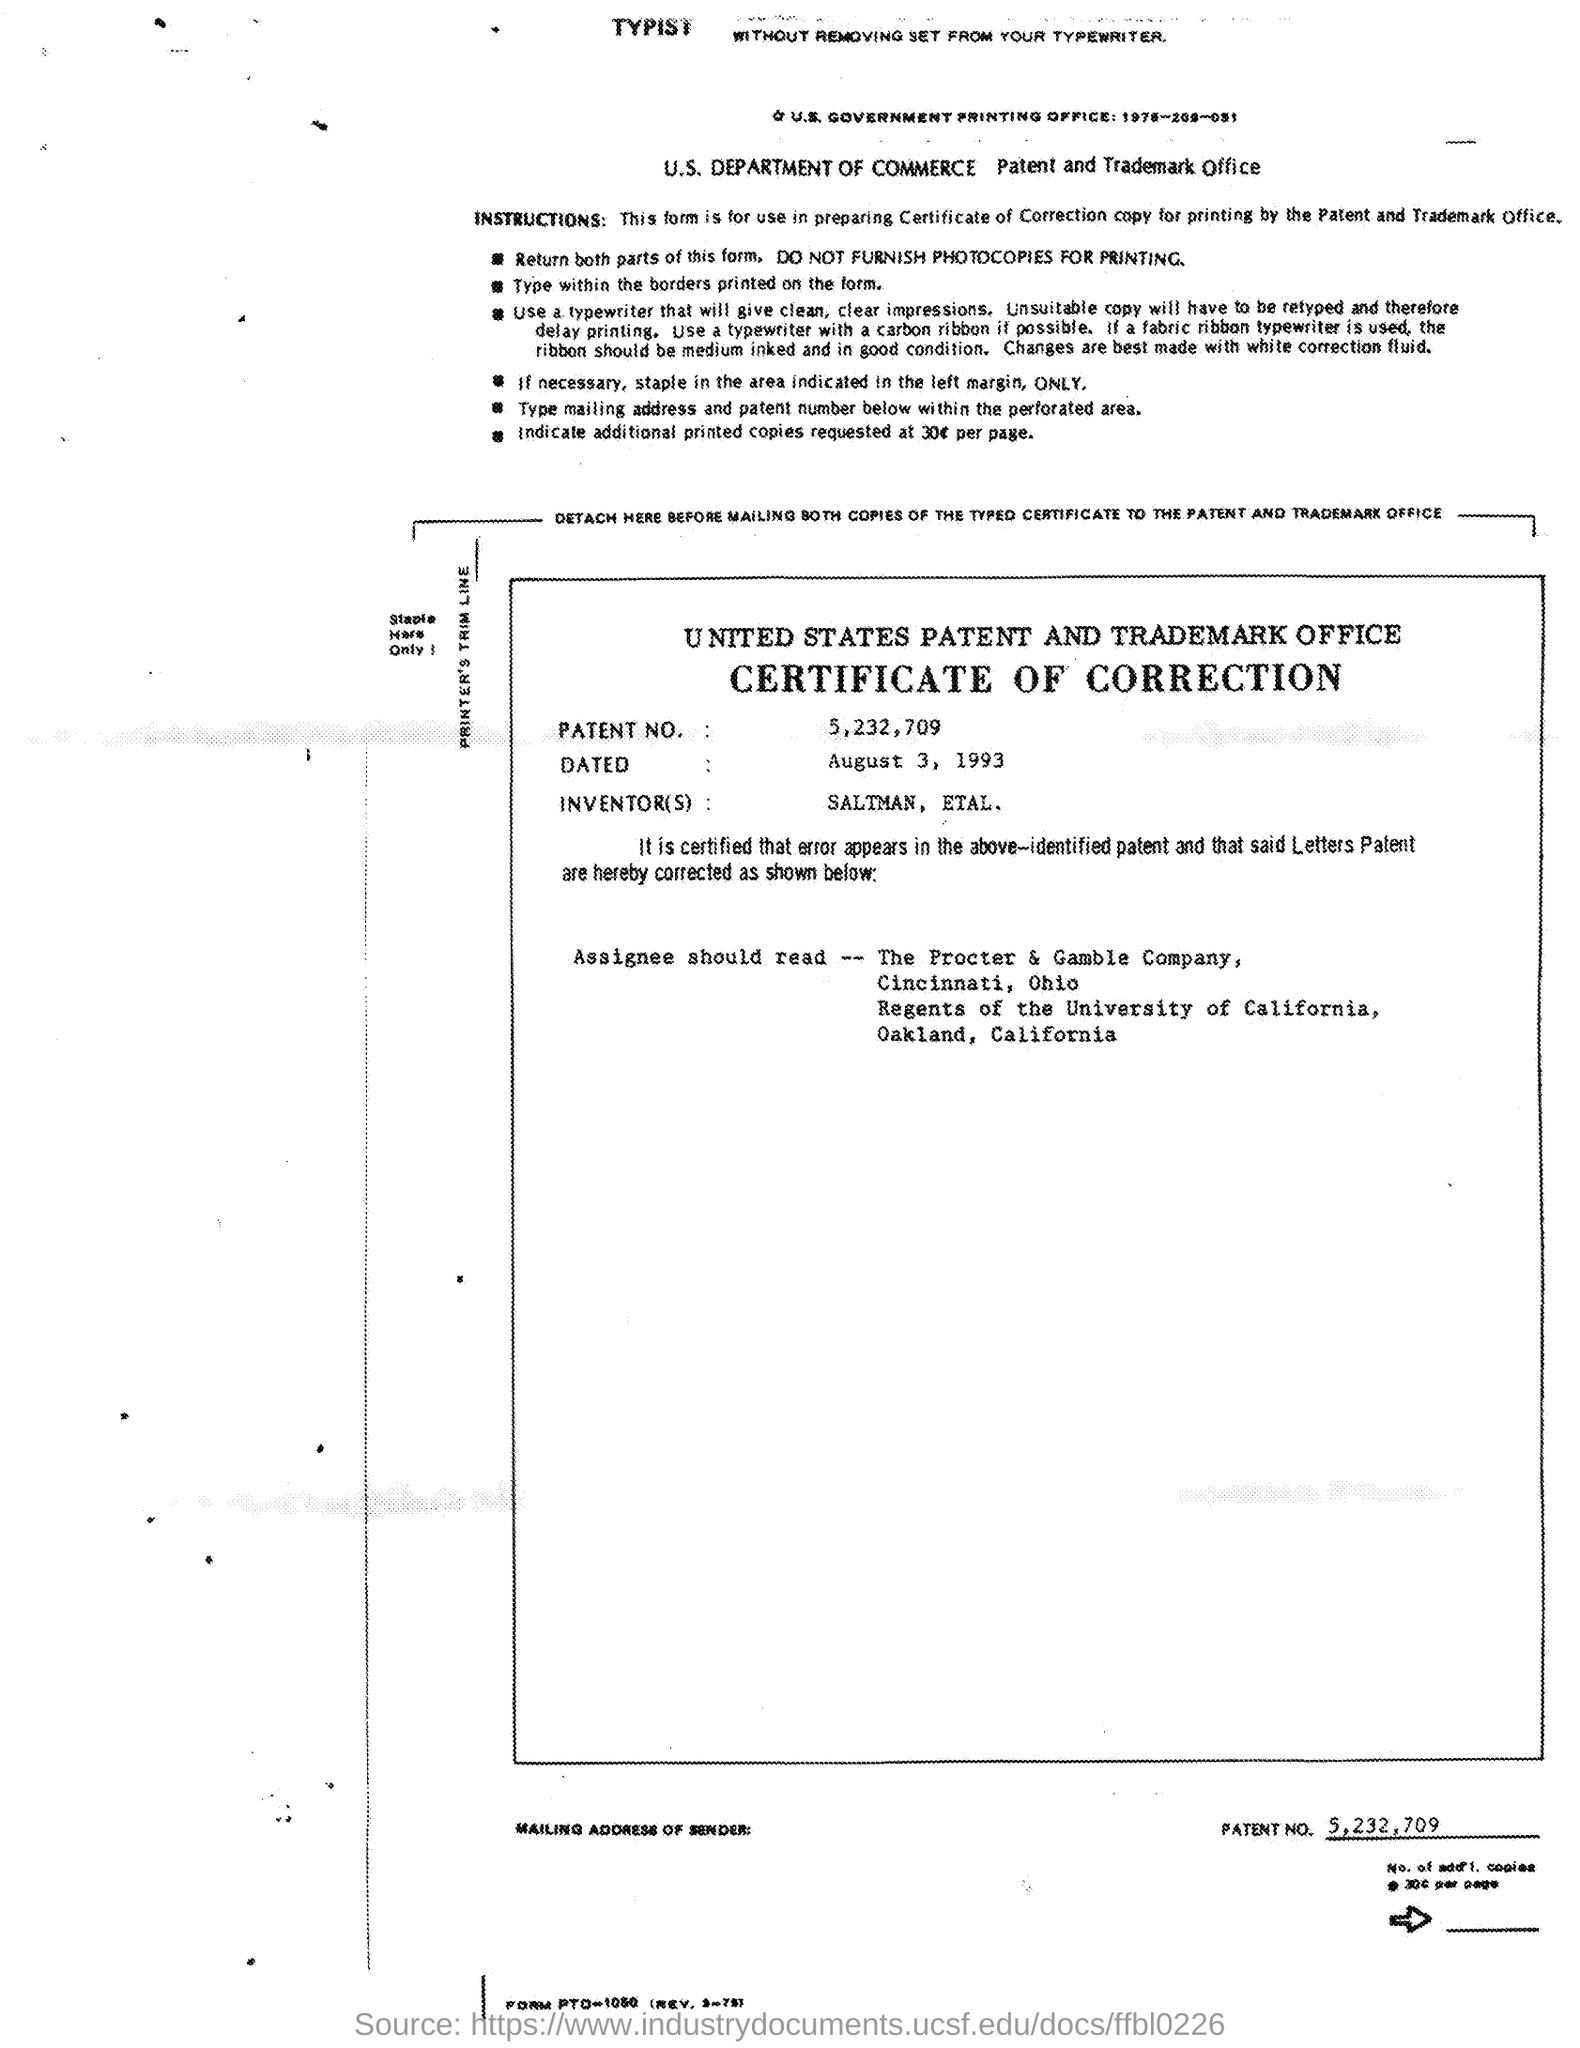What is the patent no. mentioned in the given page ?
Offer a very short reply. 5,232,709. What is the date mentioned in the given page ?
Keep it short and to the point. August 3, 1993. What are the inventors mentioned in the given page ?
Your answer should be very brief. Saltman , etal. 